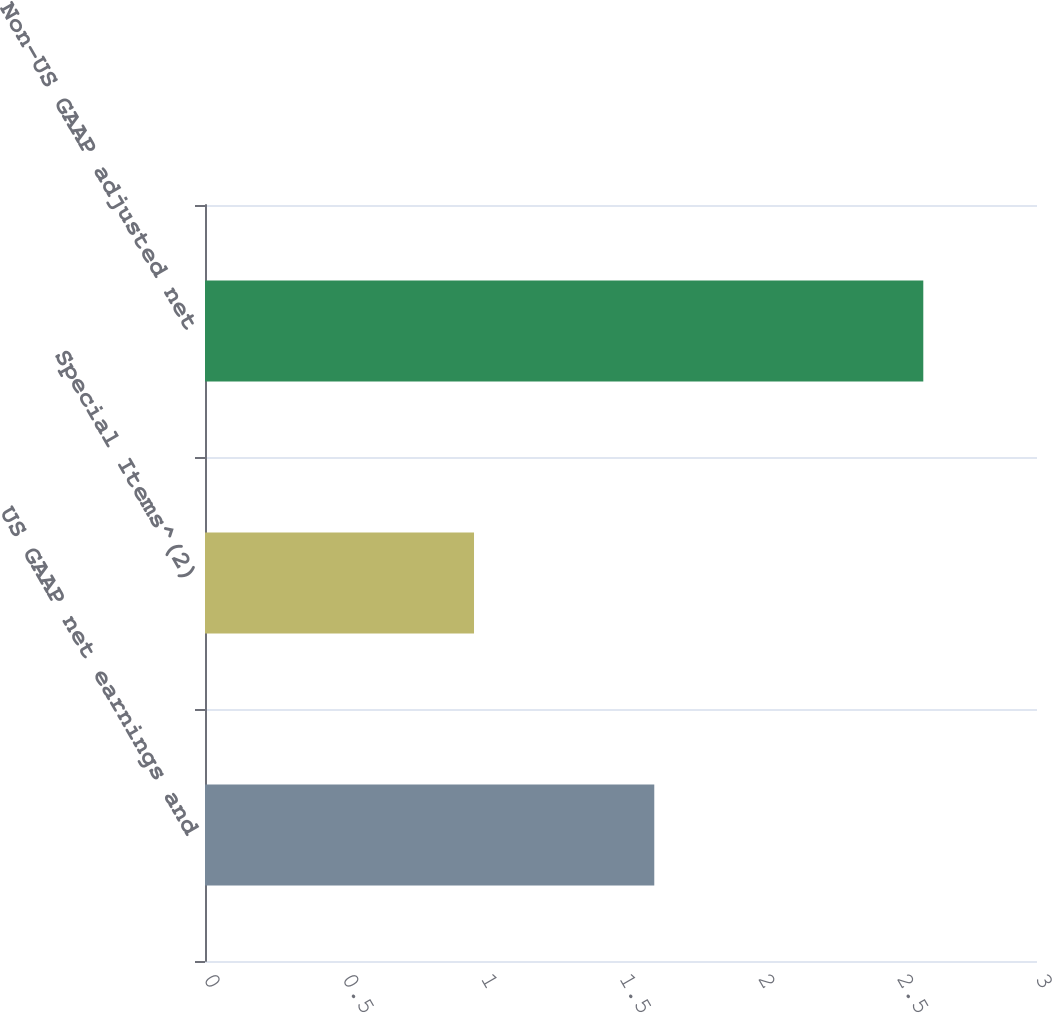Convert chart to OTSL. <chart><loc_0><loc_0><loc_500><loc_500><bar_chart><fcel>US GAAP net earnings and<fcel>Special Items^(2)<fcel>Non-US GAAP adjusted net<nl><fcel>1.62<fcel>0.97<fcel>2.59<nl></chart> 